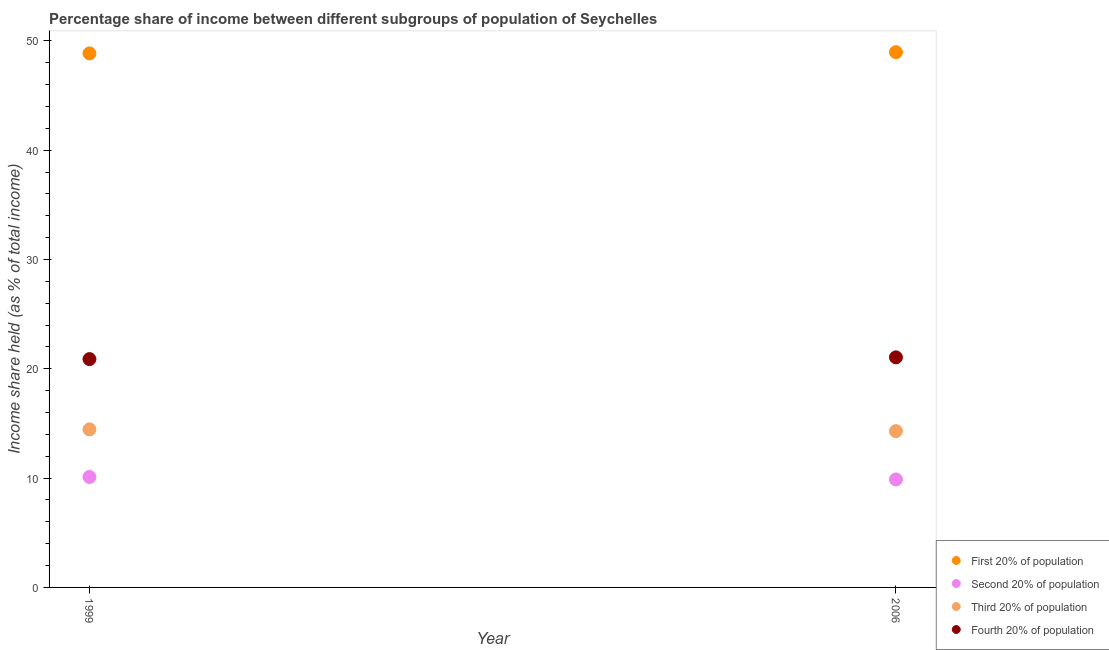Is the number of dotlines equal to the number of legend labels?
Offer a terse response. Yes. What is the share of the income held by fourth 20% of the population in 1999?
Offer a very short reply. 20.89. Across all years, what is the maximum share of the income held by fourth 20% of the population?
Offer a very short reply. 21.05. Across all years, what is the minimum share of the income held by fourth 20% of the population?
Make the answer very short. 20.89. In which year was the share of the income held by first 20% of the population maximum?
Make the answer very short. 2006. In which year was the share of the income held by first 20% of the population minimum?
Provide a succinct answer. 1999. What is the total share of the income held by third 20% of the population in the graph?
Keep it short and to the point. 28.76. What is the difference between the share of the income held by third 20% of the population in 1999 and that in 2006?
Offer a very short reply. 0.16. What is the difference between the share of the income held by third 20% of the population in 2006 and the share of the income held by first 20% of the population in 1999?
Ensure brevity in your answer.  -34.56. What is the average share of the income held by third 20% of the population per year?
Provide a short and direct response. 14.38. In the year 1999, what is the difference between the share of the income held by third 20% of the population and share of the income held by second 20% of the population?
Provide a short and direct response. 4.35. What is the ratio of the share of the income held by fourth 20% of the population in 1999 to that in 2006?
Your answer should be compact. 0.99. Is the share of the income held by second 20% of the population in 1999 less than that in 2006?
Provide a succinct answer. No. Is the share of the income held by second 20% of the population strictly less than the share of the income held by first 20% of the population over the years?
Your answer should be compact. Yes. How many dotlines are there?
Offer a very short reply. 4. Does the graph contain any zero values?
Make the answer very short. No. Does the graph contain grids?
Your answer should be compact. No. How many legend labels are there?
Your answer should be very brief. 4. What is the title of the graph?
Your answer should be very brief. Percentage share of income between different subgroups of population of Seychelles. What is the label or title of the Y-axis?
Give a very brief answer. Income share held (as % of total income). What is the Income share held (as % of total income) in First 20% of population in 1999?
Your response must be concise. 48.86. What is the Income share held (as % of total income) of Second 20% of population in 1999?
Your answer should be compact. 10.11. What is the Income share held (as % of total income) in Third 20% of population in 1999?
Offer a very short reply. 14.46. What is the Income share held (as % of total income) in Fourth 20% of population in 1999?
Give a very brief answer. 20.89. What is the Income share held (as % of total income) of First 20% of population in 2006?
Give a very brief answer. 48.97. What is the Income share held (as % of total income) in Second 20% of population in 2006?
Ensure brevity in your answer.  9.88. What is the Income share held (as % of total income) in Fourth 20% of population in 2006?
Your response must be concise. 21.05. Across all years, what is the maximum Income share held (as % of total income) of First 20% of population?
Make the answer very short. 48.97. Across all years, what is the maximum Income share held (as % of total income) in Second 20% of population?
Give a very brief answer. 10.11. Across all years, what is the maximum Income share held (as % of total income) of Third 20% of population?
Keep it short and to the point. 14.46. Across all years, what is the maximum Income share held (as % of total income) in Fourth 20% of population?
Ensure brevity in your answer.  21.05. Across all years, what is the minimum Income share held (as % of total income) of First 20% of population?
Your answer should be very brief. 48.86. Across all years, what is the minimum Income share held (as % of total income) of Second 20% of population?
Provide a succinct answer. 9.88. Across all years, what is the minimum Income share held (as % of total income) in Fourth 20% of population?
Provide a succinct answer. 20.89. What is the total Income share held (as % of total income) in First 20% of population in the graph?
Keep it short and to the point. 97.83. What is the total Income share held (as % of total income) of Second 20% of population in the graph?
Offer a terse response. 19.99. What is the total Income share held (as % of total income) in Third 20% of population in the graph?
Keep it short and to the point. 28.76. What is the total Income share held (as % of total income) in Fourth 20% of population in the graph?
Provide a short and direct response. 41.94. What is the difference between the Income share held (as % of total income) of First 20% of population in 1999 and that in 2006?
Your answer should be very brief. -0.11. What is the difference between the Income share held (as % of total income) in Second 20% of population in 1999 and that in 2006?
Offer a very short reply. 0.23. What is the difference between the Income share held (as % of total income) in Third 20% of population in 1999 and that in 2006?
Your answer should be very brief. 0.16. What is the difference between the Income share held (as % of total income) of Fourth 20% of population in 1999 and that in 2006?
Give a very brief answer. -0.16. What is the difference between the Income share held (as % of total income) in First 20% of population in 1999 and the Income share held (as % of total income) in Second 20% of population in 2006?
Your answer should be compact. 38.98. What is the difference between the Income share held (as % of total income) of First 20% of population in 1999 and the Income share held (as % of total income) of Third 20% of population in 2006?
Your answer should be very brief. 34.56. What is the difference between the Income share held (as % of total income) in First 20% of population in 1999 and the Income share held (as % of total income) in Fourth 20% of population in 2006?
Provide a succinct answer. 27.81. What is the difference between the Income share held (as % of total income) of Second 20% of population in 1999 and the Income share held (as % of total income) of Third 20% of population in 2006?
Your answer should be compact. -4.19. What is the difference between the Income share held (as % of total income) in Second 20% of population in 1999 and the Income share held (as % of total income) in Fourth 20% of population in 2006?
Make the answer very short. -10.94. What is the difference between the Income share held (as % of total income) of Third 20% of population in 1999 and the Income share held (as % of total income) of Fourth 20% of population in 2006?
Make the answer very short. -6.59. What is the average Income share held (as % of total income) in First 20% of population per year?
Give a very brief answer. 48.91. What is the average Income share held (as % of total income) of Second 20% of population per year?
Provide a short and direct response. 9.99. What is the average Income share held (as % of total income) in Third 20% of population per year?
Offer a terse response. 14.38. What is the average Income share held (as % of total income) of Fourth 20% of population per year?
Ensure brevity in your answer.  20.97. In the year 1999, what is the difference between the Income share held (as % of total income) in First 20% of population and Income share held (as % of total income) in Second 20% of population?
Provide a short and direct response. 38.75. In the year 1999, what is the difference between the Income share held (as % of total income) in First 20% of population and Income share held (as % of total income) in Third 20% of population?
Give a very brief answer. 34.4. In the year 1999, what is the difference between the Income share held (as % of total income) of First 20% of population and Income share held (as % of total income) of Fourth 20% of population?
Your answer should be compact. 27.97. In the year 1999, what is the difference between the Income share held (as % of total income) of Second 20% of population and Income share held (as % of total income) of Third 20% of population?
Offer a very short reply. -4.35. In the year 1999, what is the difference between the Income share held (as % of total income) in Second 20% of population and Income share held (as % of total income) in Fourth 20% of population?
Your answer should be compact. -10.78. In the year 1999, what is the difference between the Income share held (as % of total income) in Third 20% of population and Income share held (as % of total income) in Fourth 20% of population?
Give a very brief answer. -6.43. In the year 2006, what is the difference between the Income share held (as % of total income) of First 20% of population and Income share held (as % of total income) of Second 20% of population?
Offer a terse response. 39.09. In the year 2006, what is the difference between the Income share held (as % of total income) of First 20% of population and Income share held (as % of total income) of Third 20% of population?
Offer a very short reply. 34.67. In the year 2006, what is the difference between the Income share held (as % of total income) in First 20% of population and Income share held (as % of total income) in Fourth 20% of population?
Give a very brief answer. 27.92. In the year 2006, what is the difference between the Income share held (as % of total income) of Second 20% of population and Income share held (as % of total income) of Third 20% of population?
Keep it short and to the point. -4.42. In the year 2006, what is the difference between the Income share held (as % of total income) of Second 20% of population and Income share held (as % of total income) of Fourth 20% of population?
Give a very brief answer. -11.17. In the year 2006, what is the difference between the Income share held (as % of total income) in Third 20% of population and Income share held (as % of total income) in Fourth 20% of population?
Ensure brevity in your answer.  -6.75. What is the ratio of the Income share held (as % of total income) of First 20% of population in 1999 to that in 2006?
Offer a very short reply. 1. What is the ratio of the Income share held (as % of total income) of Second 20% of population in 1999 to that in 2006?
Offer a very short reply. 1.02. What is the ratio of the Income share held (as % of total income) in Third 20% of population in 1999 to that in 2006?
Ensure brevity in your answer.  1.01. What is the difference between the highest and the second highest Income share held (as % of total income) in First 20% of population?
Your answer should be compact. 0.11. What is the difference between the highest and the second highest Income share held (as % of total income) of Second 20% of population?
Offer a terse response. 0.23. What is the difference between the highest and the second highest Income share held (as % of total income) in Third 20% of population?
Provide a succinct answer. 0.16. What is the difference between the highest and the second highest Income share held (as % of total income) in Fourth 20% of population?
Give a very brief answer. 0.16. What is the difference between the highest and the lowest Income share held (as % of total income) of First 20% of population?
Your answer should be very brief. 0.11. What is the difference between the highest and the lowest Income share held (as % of total income) in Second 20% of population?
Make the answer very short. 0.23. What is the difference between the highest and the lowest Income share held (as % of total income) in Third 20% of population?
Your answer should be very brief. 0.16. What is the difference between the highest and the lowest Income share held (as % of total income) of Fourth 20% of population?
Give a very brief answer. 0.16. 